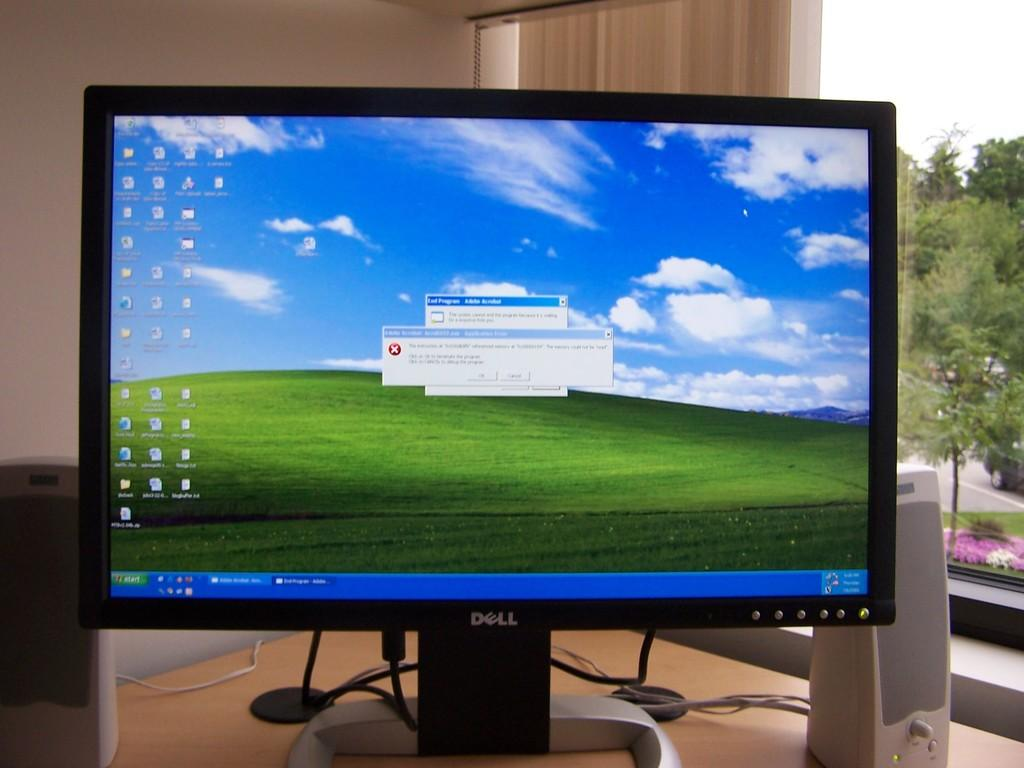<image>
Write a terse but informative summary of the picture. Dell computer monitor showing a cloudy blue sky. 